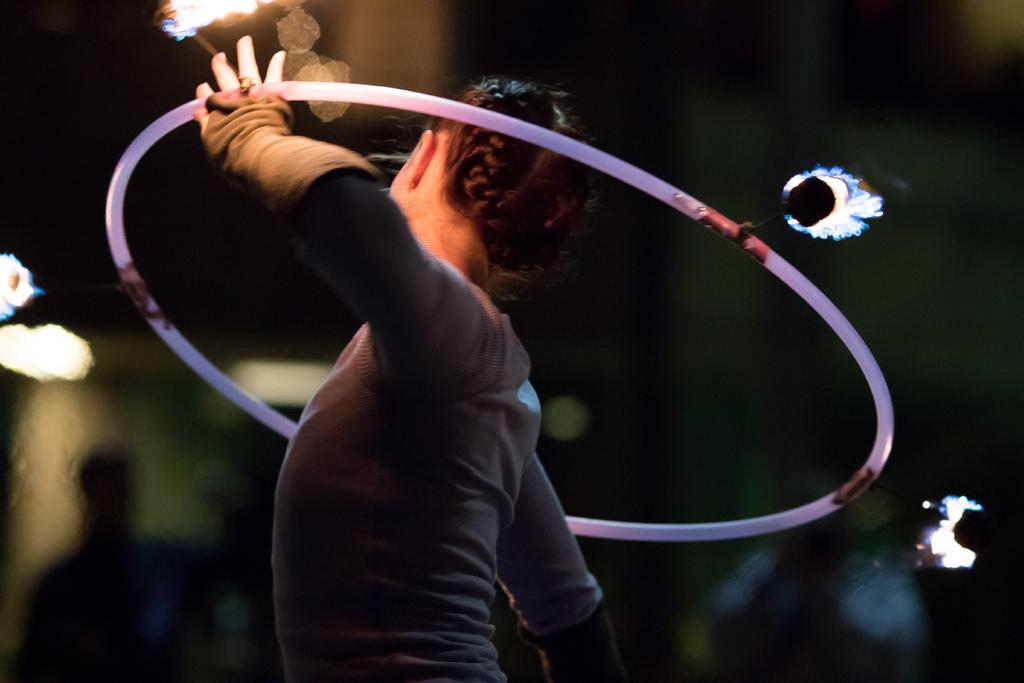What is the main subject of the image? There is a person standing in the middle of the image. What is the person holding in the image? The person is holding a ring. Can you describe the background of the image? The background of the image is blurred. What type of paper can be seen being laughed at by the person in the image? There is no paper or laughter present in the image; it features a person holding a ring with a blurred background. 